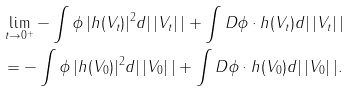<formula> <loc_0><loc_0><loc_500><loc_500>& \lim _ { t \rightarrow 0 ^ { + } } - \int \phi \, | h ( V _ { t } ) | ^ { 2 } d | \, | V _ { t } | \, | + \int D \phi \cdot h ( V _ { t } ) d | \, | V _ { t } | \, | \\ & = - \int \phi \, | h ( V _ { 0 } ) | ^ { 2 } d | \, | V _ { 0 } | \, | + \int D \phi \cdot h ( V _ { 0 } ) d | \, | V _ { 0 } | \, | .</formula> 